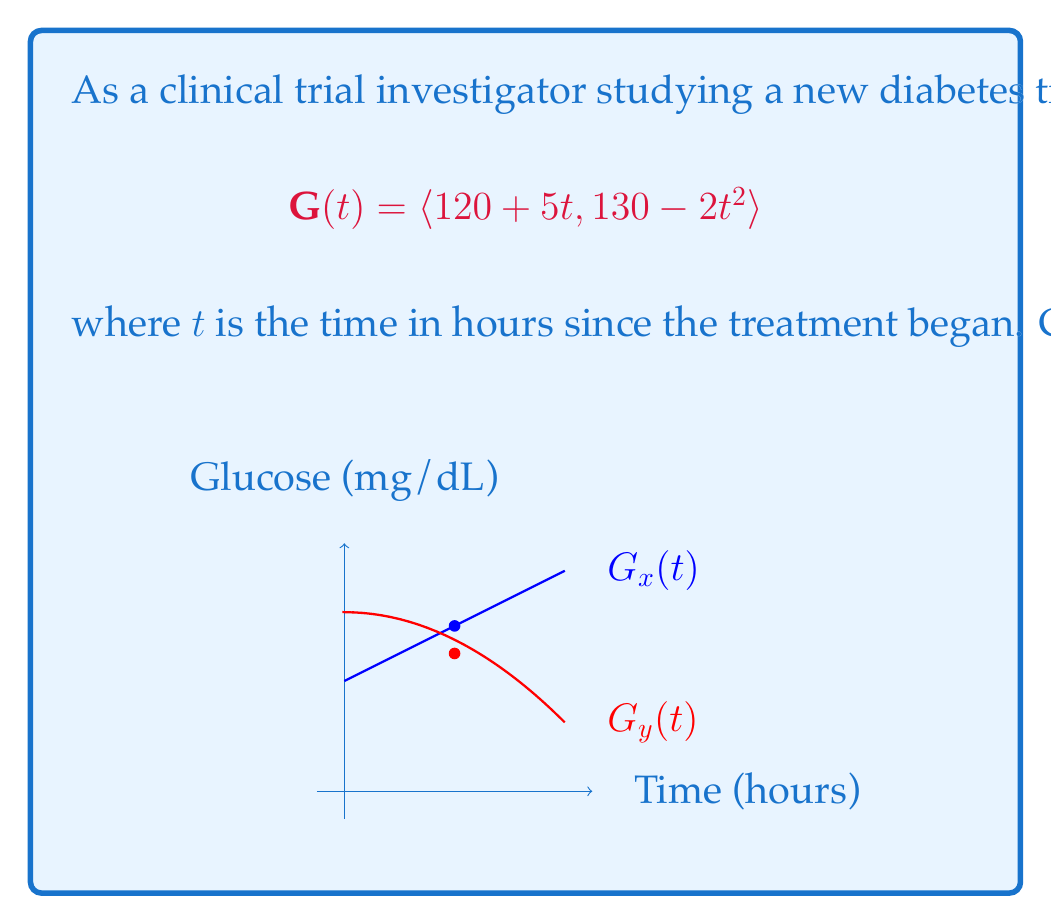What is the answer to this math problem? To solve this problem, we need to follow these steps:

1) The vector function $\mathbf{G}(t)$ represents the blood glucose levels over time. The x-component represents one aspect of glucose levels, while the y-component represents another.

2) To find the rate of change, we need to calculate the derivative of $\mathbf{G}(t)$ with respect to $t$:

   $$\frac{d\mathbf{G}}{dt} = \langle \frac{d}{dt}(120 + 5t), \frac{d}{dt}(130 - 2t^2) \rangle$$

3) Calculating the derivatives:
   
   $$\frac{d\mathbf{G}}{dt} = \langle 5, -4t \rangle$$

4) This derivative vector represents the instantaneous rate of change of blood glucose levels at any time $t$.

5) To find the rate of change at $t = 2$ hours, we substitute $t = 2$ into our derivative vector:

   $$\frac{d\mathbf{G}}{dt}|_{t=2} = \langle 5, -4(2) \rangle = \langle 5, -8 \rangle$$

6) This result means that at $t = 2$ hours:
   - The x-component of glucose levels is increasing at a rate of 5 mg/dL per hour
   - The y-component of glucose levels is decreasing at a rate of 8 mg/dL per hour

7) To get the magnitude of this rate of change, we can calculate the length of this vector:

   $$\left|\frac{d\mathbf{G}}{dt}|_{t=2}\right| = \sqrt{5^2 + (-8)^2} = \sqrt{25 + 64} = \sqrt{89} \approx 9.43$$

Therefore, the overall rate of change in blood glucose levels at $t = 2$ hours is approximately 9.43 mg/dL per hour.
Answer: $\langle 5, -8 \rangle$ mg/dL per hour, with magnitude $\sqrt{89} \approx 9.43$ mg/dL per hour 